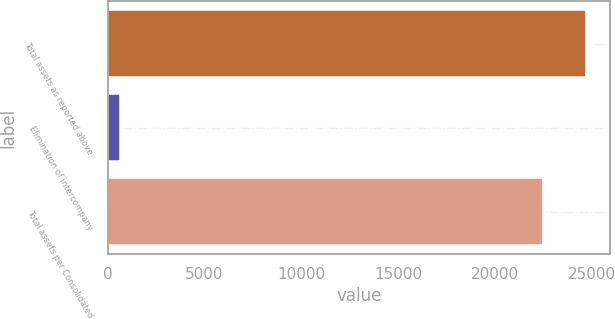<chart> <loc_0><loc_0><loc_500><loc_500><bar_chart><fcel>Total assets as reported above<fcel>Elimination of intercompany<fcel>Total assets per Consolidated<nl><fcel>24739<fcel>612<fcel>22490<nl></chart> 